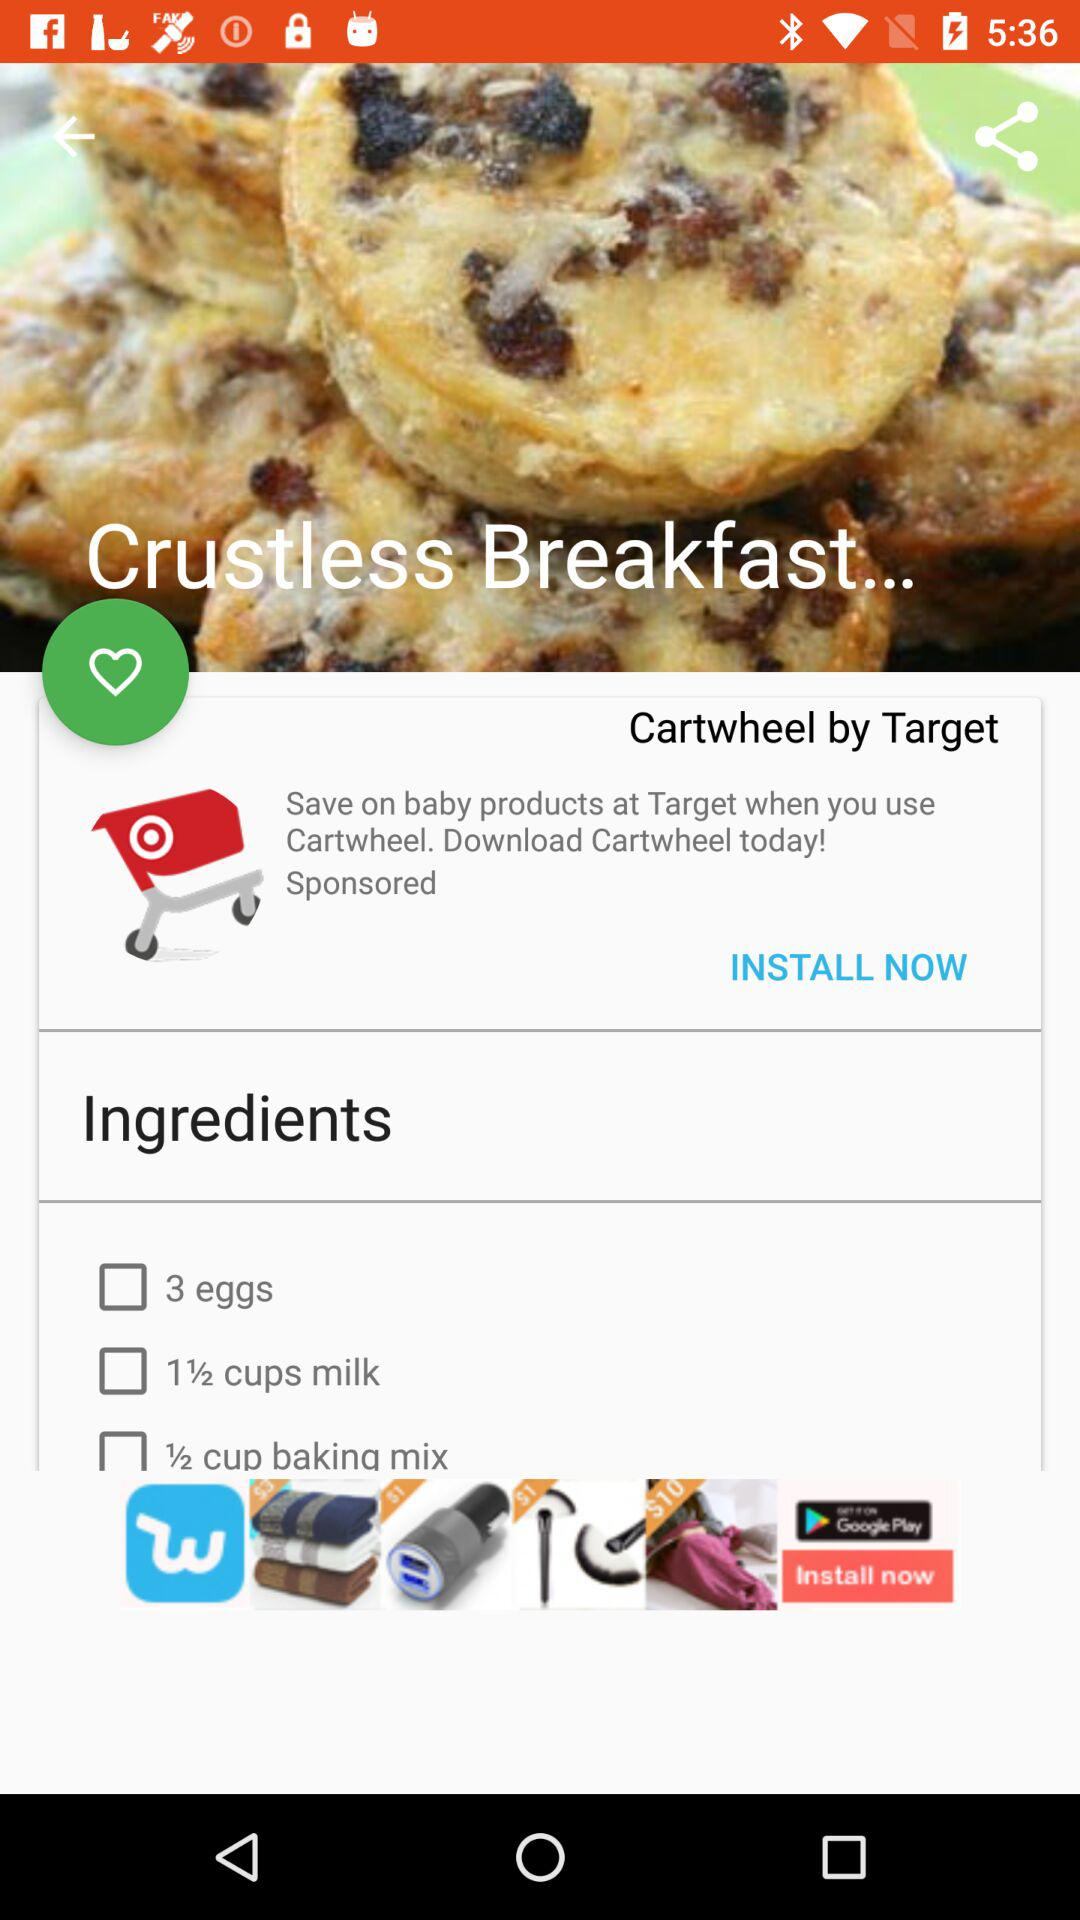How many ingredients are there in the recipe?
Answer the question using a single word or phrase. 3 